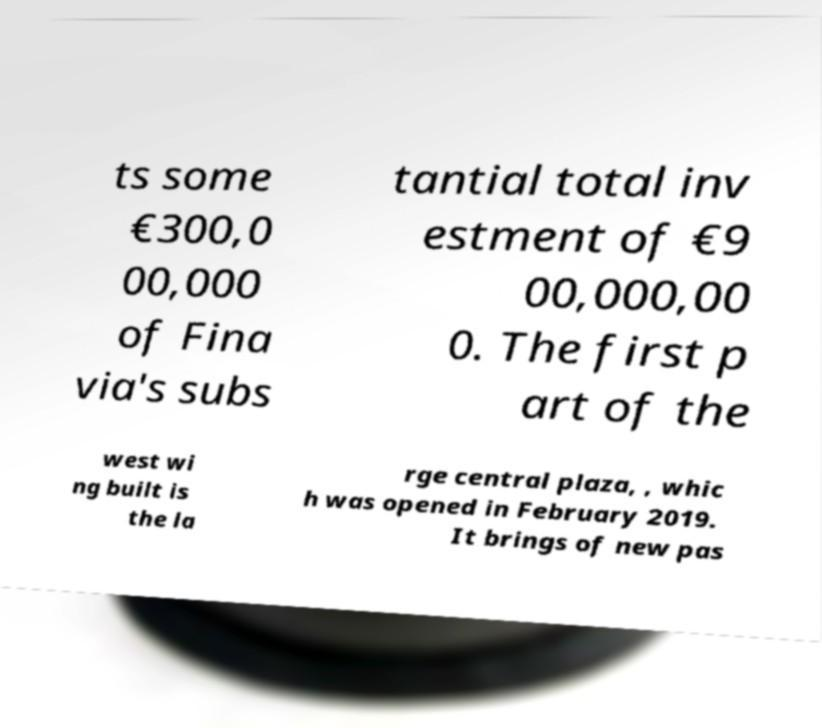Please identify and transcribe the text found in this image. ts some €300,0 00,000 of Fina via's subs tantial total inv estment of €9 00,000,00 0. The first p art of the west wi ng built is the la rge central plaza, , whic h was opened in February 2019. It brings of new pas 